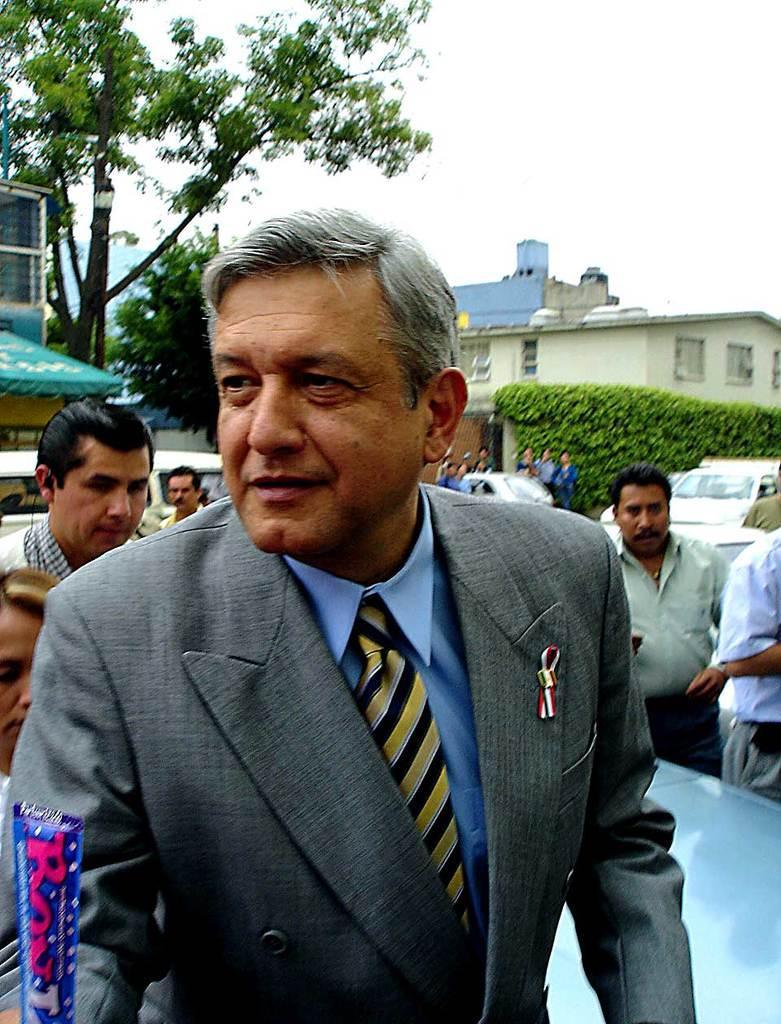Please provide a concise description of this image. In this image, we can see an old man in a suit. Background we can see few vehicles, people, houses, plants, trees, walls, windows and sky. Left side bottom corner we can see some object in blue color. 